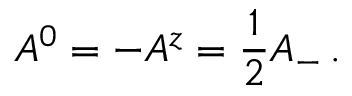<formula> <loc_0><loc_0><loc_500><loc_500>A ^ { 0 } = - A ^ { z } = \frac { 1 } { 2 } A _ { - } \, .</formula> 